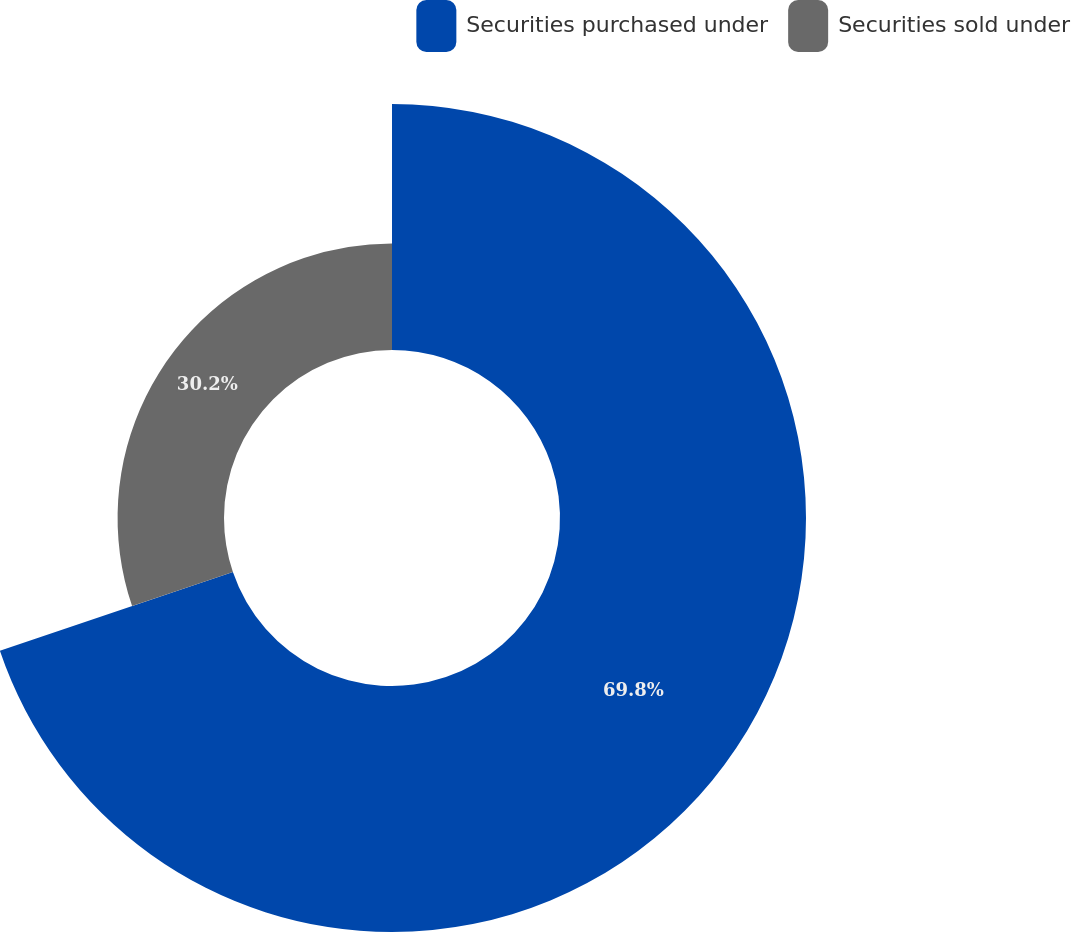Convert chart. <chart><loc_0><loc_0><loc_500><loc_500><pie_chart><fcel>Securities purchased under<fcel>Securities sold under<nl><fcel>69.8%<fcel>30.2%<nl></chart> 